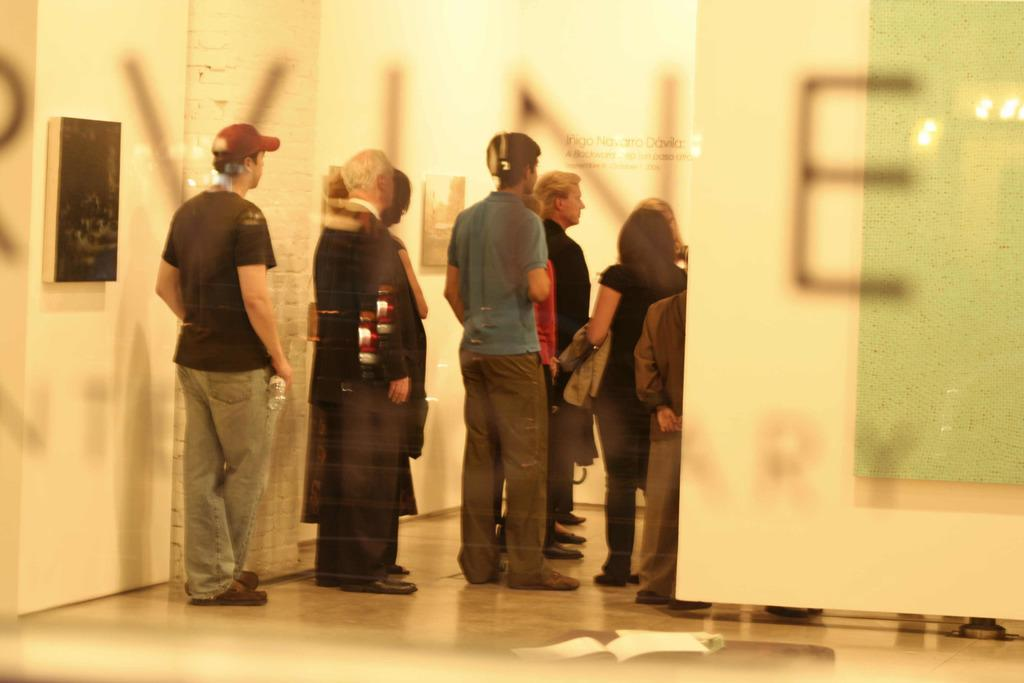What type of door is visible in the image? There is a glass door in the image. What can be seen on the glass door? There is text written on the glass door. What is visible through the glass door? Persons standing on the floor and frames are visible through the glass door. What is on the wall, visible through the glass door? There is a name board on the wall, visible through the glass door. What country is being cooked in the image? There is no mention of cooking or a specific country in the image. 